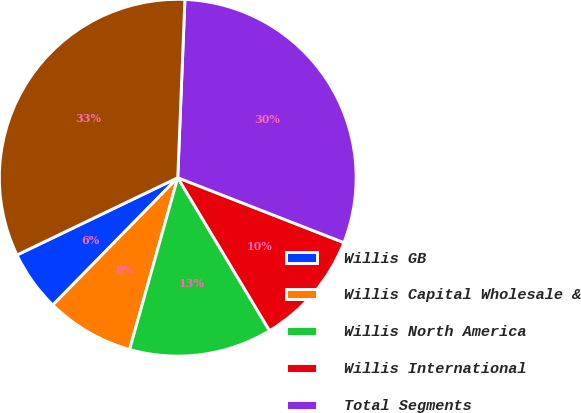Convert chart. <chart><loc_0><loc_0><loc_500><loc_500><pie_chart><fcel>Willis GB<fcel>Willis Capital Wholesale &<fcel>Willis North America<fcel>Willis International<fcel>Total Segments<fcel>Total Consolidated<nl><fcel>5.52%<fcel>8.0%<fcel>12.95%<fcel>10.47%<fcel>30.29%<fcel>32.77%<nl></chart> 